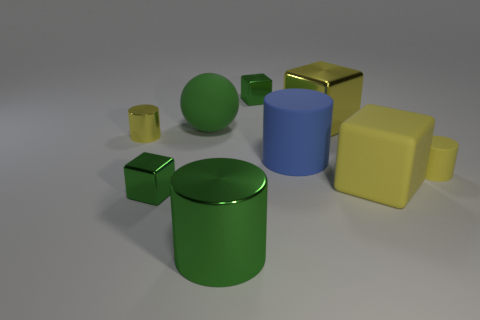Subtract all blue blocks. Subtract all green cylinders. How many blocks are left? 4 Subtract all cylinders. How many objects are left? 5 Add 1 tiny green metallic blocks. How many tiny green metallic blocks are left? 3 Add 5 large blue cylinders. How many large blue cylinders exist? 6 Subtract 0 cyan cubes. How many objects are left? 9 Subtract all green balls. Subtract all large green shiny objects. How many objects are left? 7 